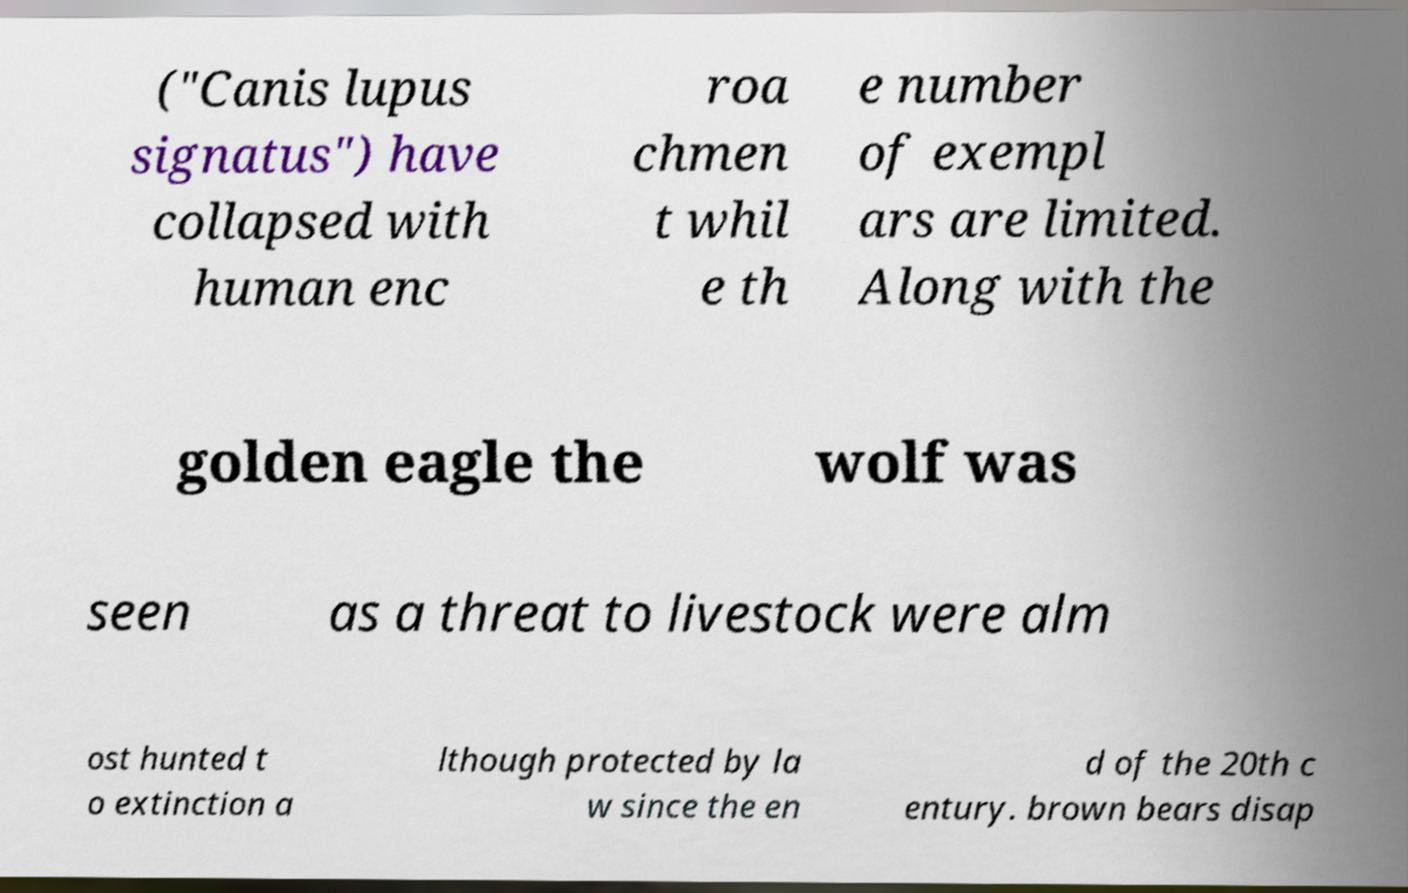Please identify and transcribe the text found in this image. ("Canis lupus signatus") have collapsed with human enc roa chmen t whil e th e number of exempl ars are limited. Along with the golden eagle the wolf was seen as a threat to livestock were alm ost hunted t o extinction a lthough protected by la w since the en d of the 20th c entury. brown bears disap 